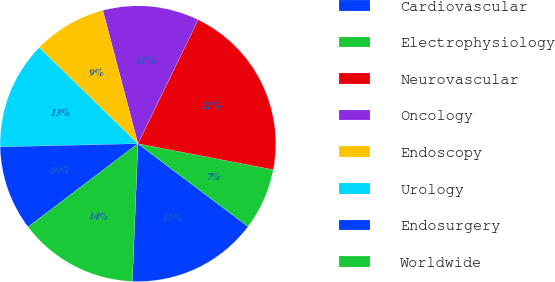Convert chart to OTSL. <chart><loc_0><loc_0><loc_500><loc_500><pie_chart><fcel>Cardiovascular<fcel>Electrophysiology<fcel>Neurovascular<fcel>Oncology<fcel>Endoscopy<fcel>Urology<fcel>Endosurgery<fcel>Worldwide<nl><fcel>15.38%<fcel>7.24%<fcel>20.81%<fcel>11.31%<fcel>8.6%<fcel>12.67%<fcel>9.95%<fcel>14.03%<nl></chart> 